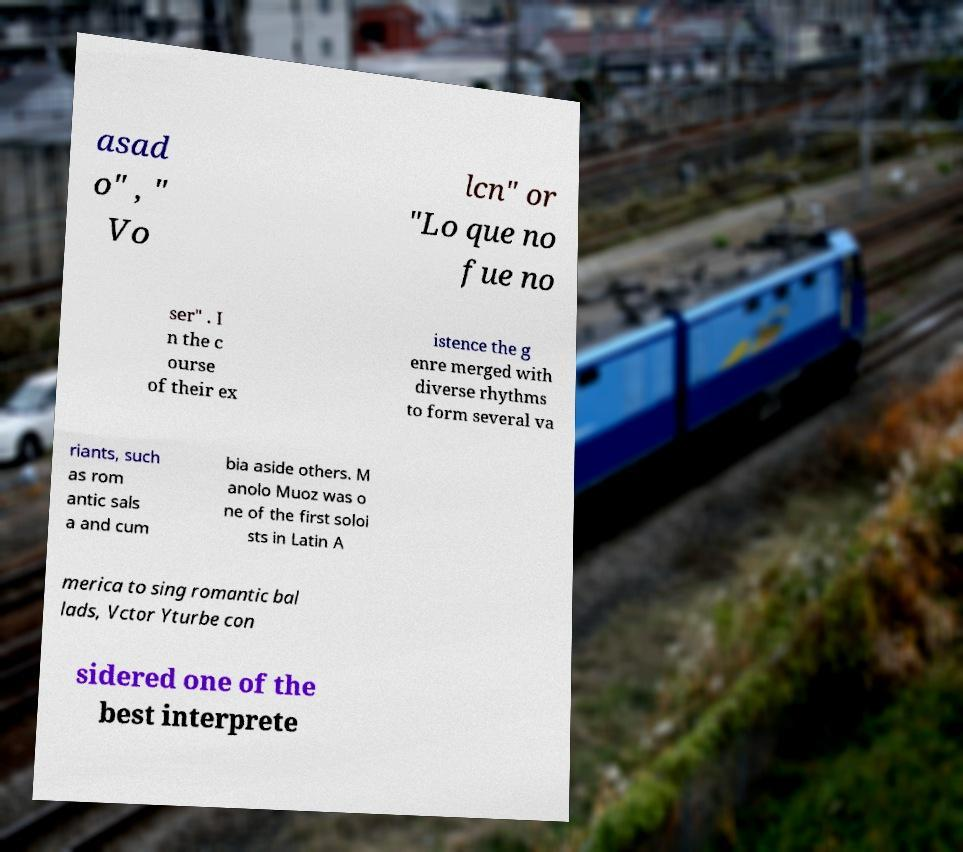There's text embedded in this image that I need extracted. Can you transcribe it verbatim? asad o" , " Vo lcn" or "Lo que no fue no ser" . I n the c ourse of their ex istence the g enre merged with diverse rhythms to form several va riants, such as rom antic sals a and cum bia aside others. M anolo Muoz was o ne of the first soloi sts in Latin A merica to sing romantic bal lads, Vctor Yturbe con sidered one of the best interprete 